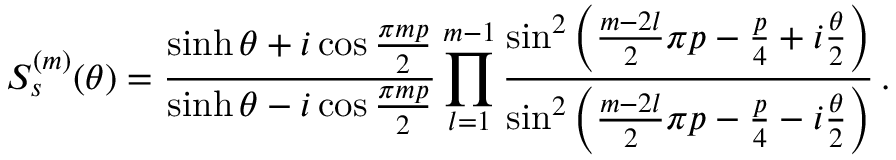Convert formula to latex. <formula><loc_0><loc_0><loc_500><loc_500>S _ { s } ^ { ( m ) } ( \theta ) = \frac { \sinh \theta + i \cos \frac { \pi m p } { 2 } } { \sinh \theta - i \cos \frac { \pi m p } { 2 } } \prod _ { l = 1 } ^ { m - 1 } \frac { \sin ^ { 2 } \left ( \frac { m - 2 l } { 2 } \pi p - \frac { p } { 4 } + i \frac { \theta } { 2 } \right ) } { \sin ^ { 2 } \left ( \frac { m - 2 l } { 2 } \pi p - \frac { p } { 4 } - i \frac { \theta } { 2 } \right ) } \, .</formula> 